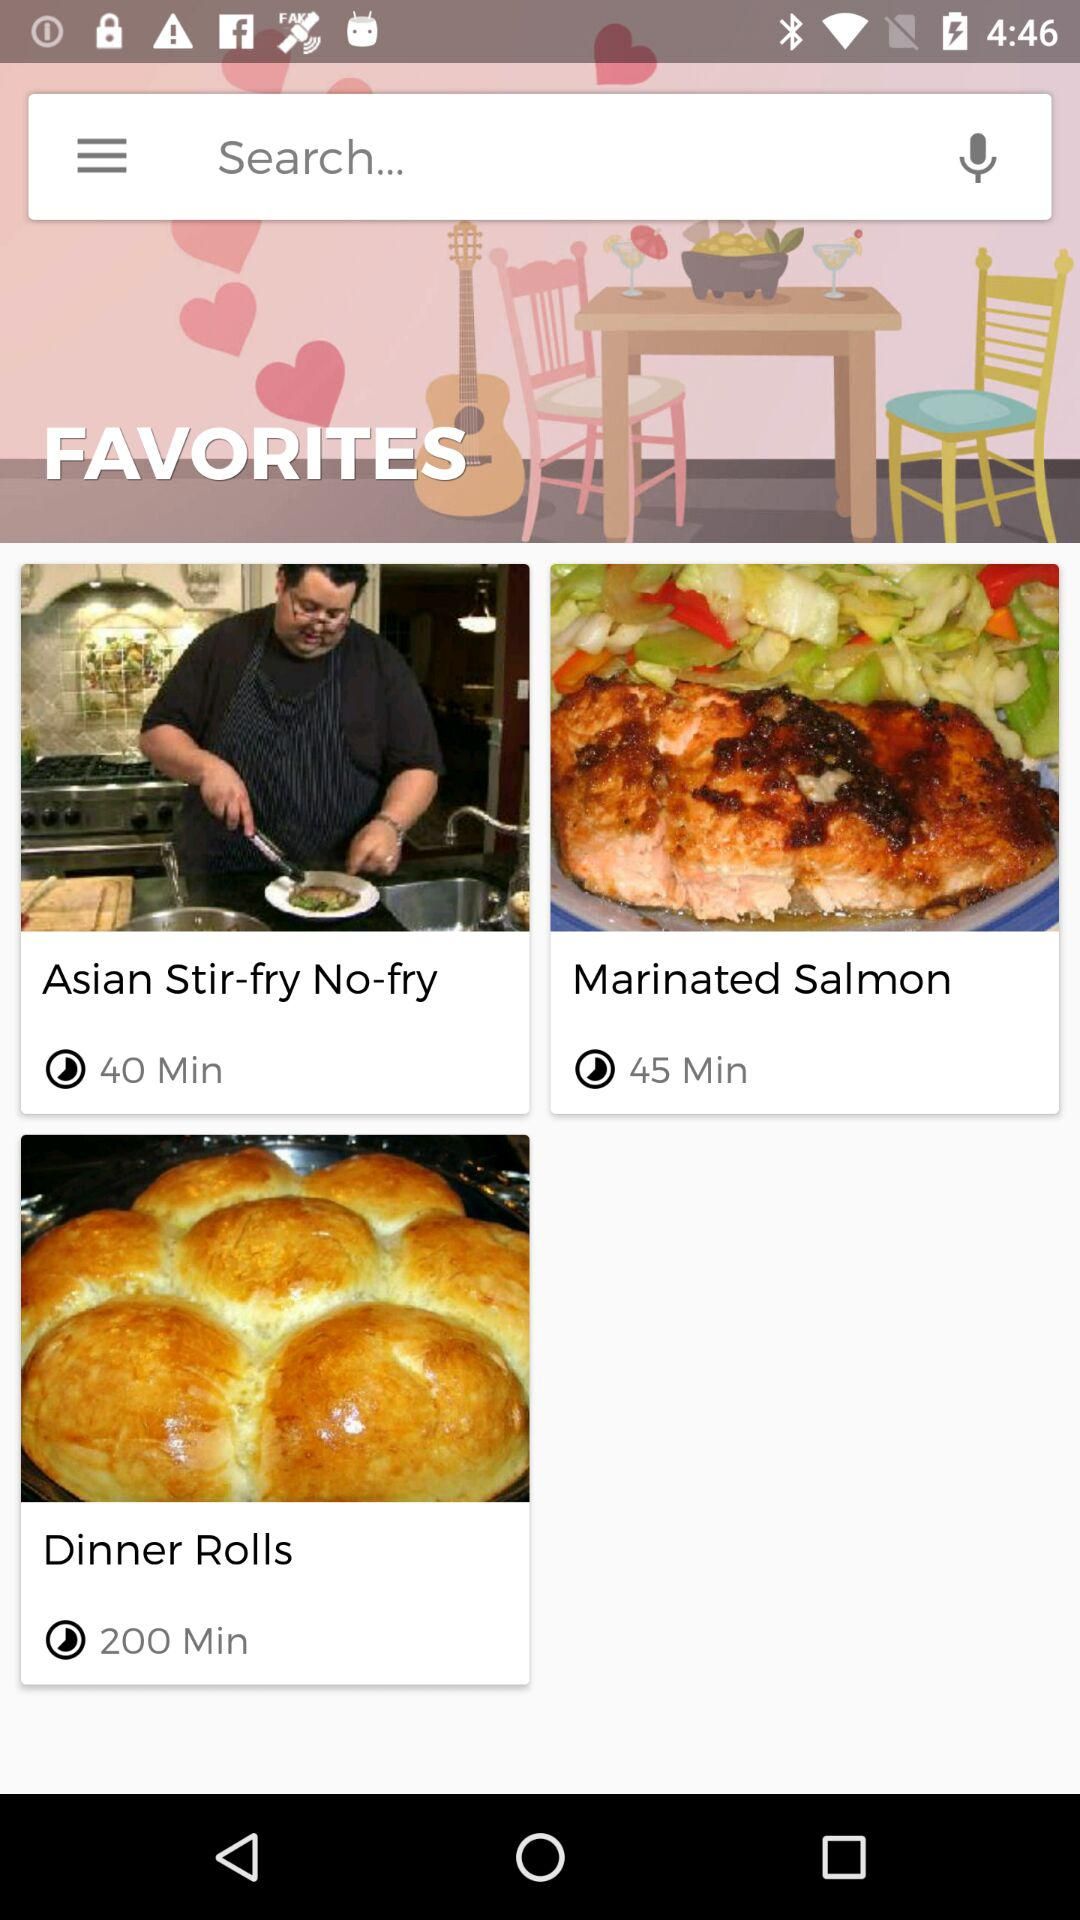What is the duration of the video "Marinated Salmon"? The duration of the video "Marinated Salmon" is 45 minutes. 